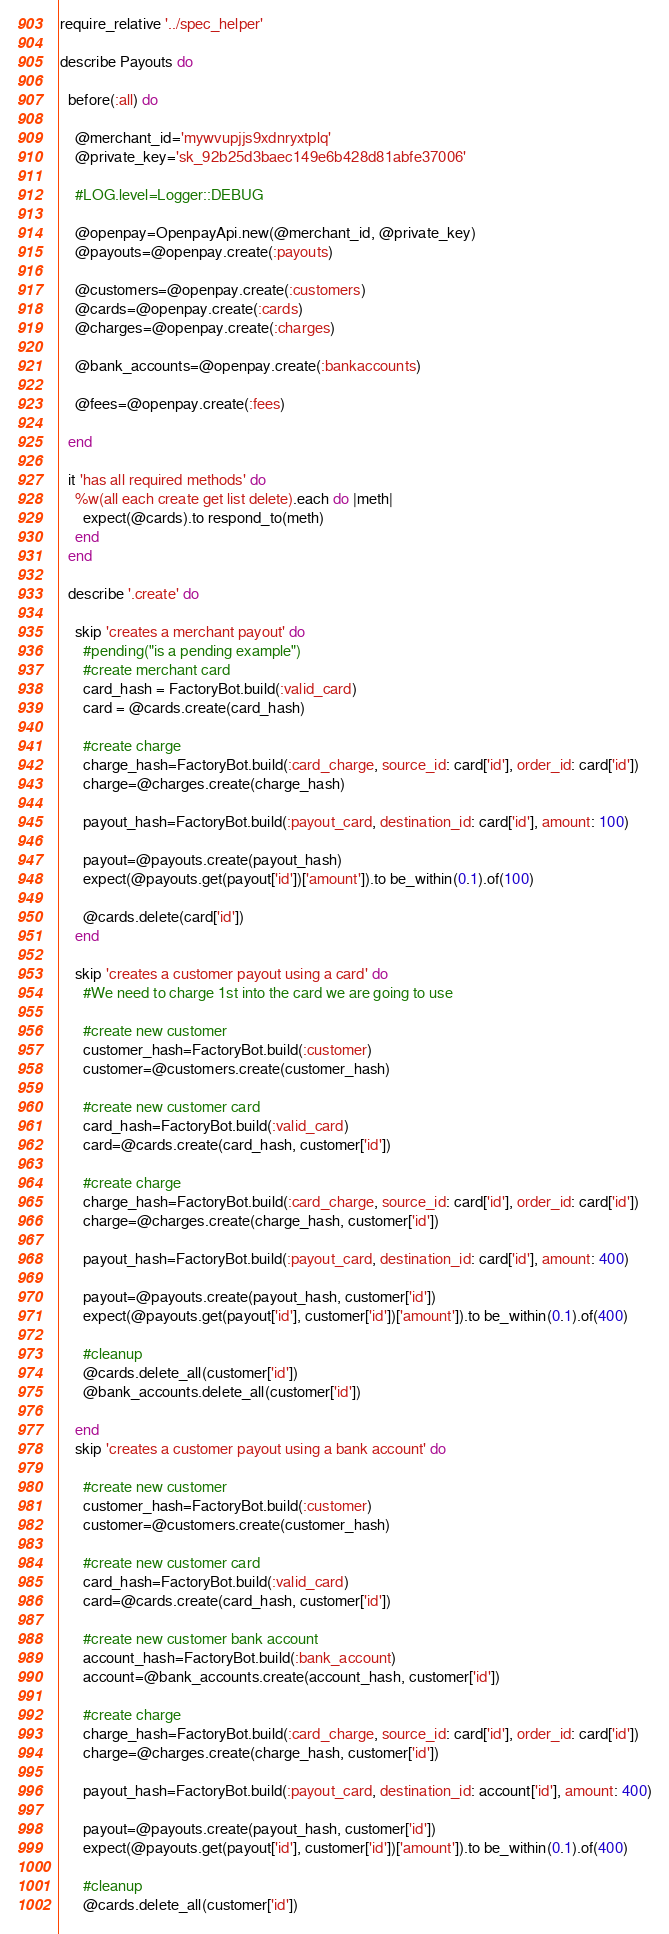<code> <loc_0><loc_0><loc_500><loc_500><_Ruby_>require_relative '../spec_helper'

describe Payouts do

  before(:all) do

    @merchant_id='mywvupjjs9xdnryxtplq'
    @private_key='sk_92b25d3baec149e6b428d81abfe37006'
    
    #LOG.level=Logger::DEBUG

    @openpay=OpenpayApi.new(@merchant_id, @private_key)
    @payouts=@openpay.create(:payouts)

    @customers=@openpay.create(:customers)
    @cards=@openpay.create(:cards)
    @charges=@openpay.create(:charges)

    @bank_accounts=@openpay.create(:bankaccounts)

    @fees=@openpay.create(:fees)

  end

  it 'has all required methods' do
    %w(all each create get list delete).each do |meth|
      expect(@cards).to respond_to(meth)
    end
  end

  describe '.create' do

    skip 'creates a merchant payout' do
      #pending("is a pending example")
      #create merchant card
      card_hash = FactoryBot.build(:valid_card)
      card = @cards.create(card_hash)

      #create charge
      charge_hash=FactoryBot.build(:card_charge, source_id: card['id'], order_id: card['id'])
      charge=@charges.create(charge_hash)

      payout_hash=FactoryBot.build(:payout_card, destination_id: card['id'], amount: 100)

      payout=@payouts.create(payout_hash)
      expect(@payouts.get(payout['id'])['amount']).to be_within(0.1).of(100)

      @cards.delete(card['id'])
    end
    
    skip 'creates a customer payout using a card' do
      #We need to charge 1st into the card we are going to use

      #create new customer
      customer_hash=FactoryBot.build(:customer)
      customer=@customers.create(customer_hash)

      #create new customer card
      card_hash=FactoryBot.build(:valid_card)
      card=@cards.create(card_hash, customer['id'])

      #create charge
      charge_hash=FactoryBot.build(:card_charge, source_id: card['id'], order_id: card['id'])
      charge=@charges.create(charge_hash, customer['id'])

      payout_hash=FactoryBot.build(:payout_card, destination_id: card['id'], amount: 400)

      payout=@payouts.create(payout_hash, customer['id'])
      expect(@payouts.get(payout['id'], customer['id'])['amount']).to be_within(0.1).of(400)

      #cleanup
      @cards.delete_all(customer['id'])
      @bank_accounts.delete_all(customer['id'])

    end
    skip 'creates a customer payout using a bank account' do

      #create new customer
      customer_hash=FactoryBot.build(:customer)
      customer=@customers.create(customer_hash)

      #create new customer card
      card_hash=FactoryBot.build(:valid_card)
      card=@cards.create(card_hash, customer['id'])

      #create new customer bank account
      account_hash=FactoryBot.build(:bank_account)
      account=@bank_accounts.create(account_hash, customer['id'])

      #create charge
      charge_hash=FactoryBot.build(:card_charge, source_id: card['id'], order_id: card['id'])
      charge=@charges.create(charge_hash, customer['id'])

      payout_hash=FactoryBot.build(:payout_card, destination_id: account['id'], amount: 400)

      payout=@payouts.create(payout_hash, customer['id'])
      expect(@payouts.get(payout['id'], customer['id'])['amount']).to be_within(0.1).of(400)

      #cleanup
      @cards.delete_all(customer['id'])</code> 